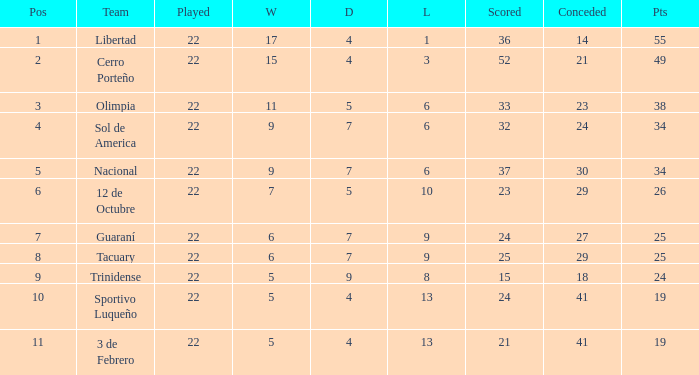What was the number of losses when the scored value was 25? 9.0. 